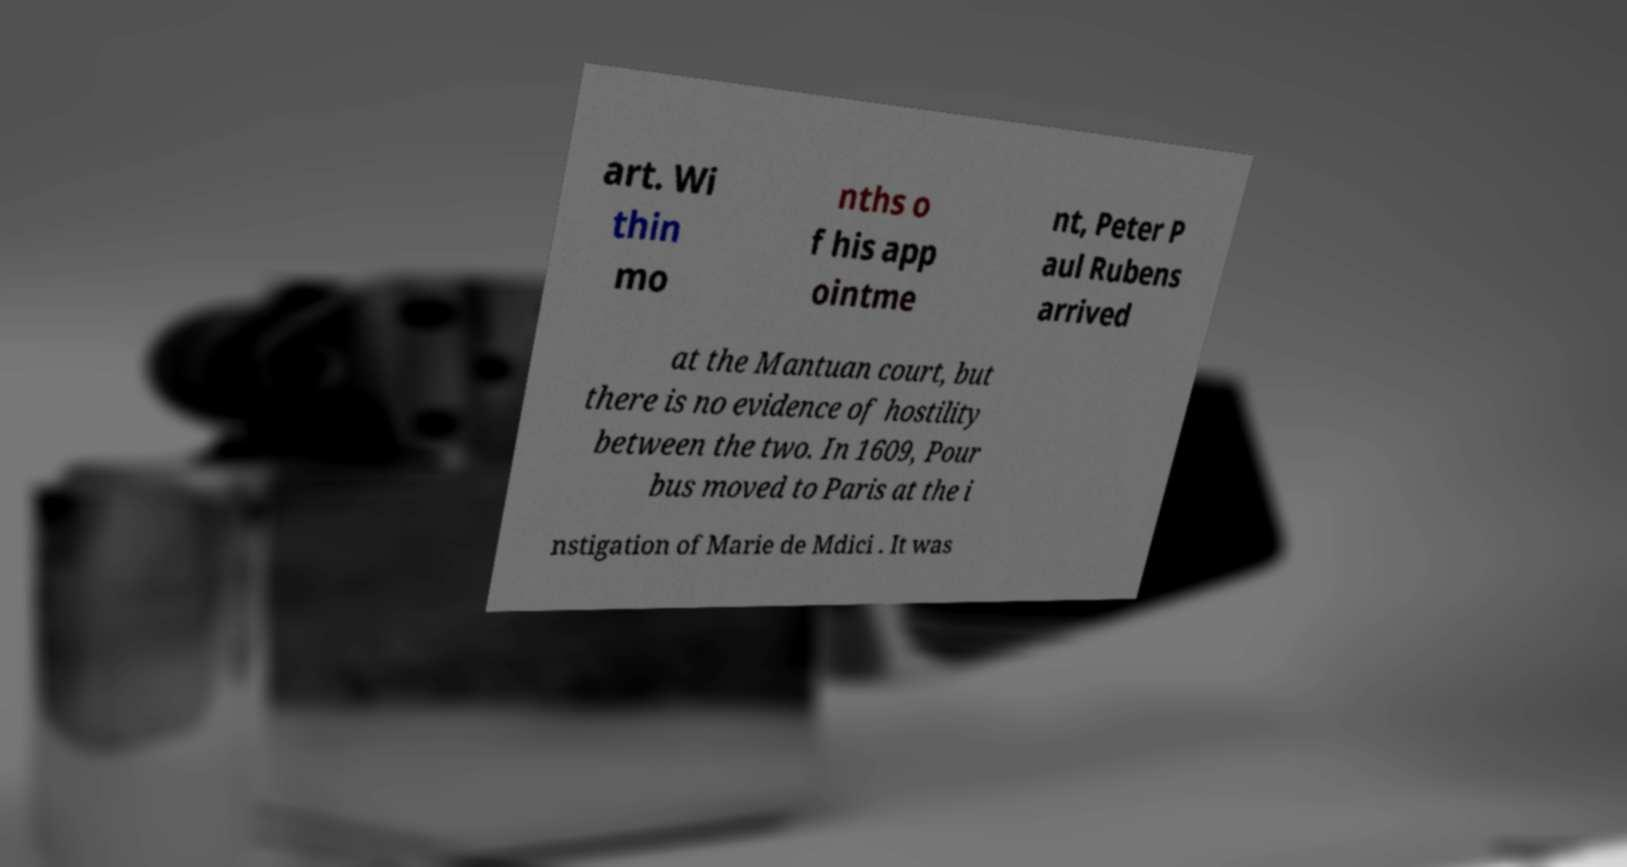What messages or text are displayed in this image? I need them in a readable, typed format. art. Wi thin mo nths o f his app ointme nt, Peter P aul Rubens arrived at the Mantuan court, but there is no evidence of hostility between the two. In 1609, Pour bus moved to Paris at the i nstigation of Marie de Mdici . It was 